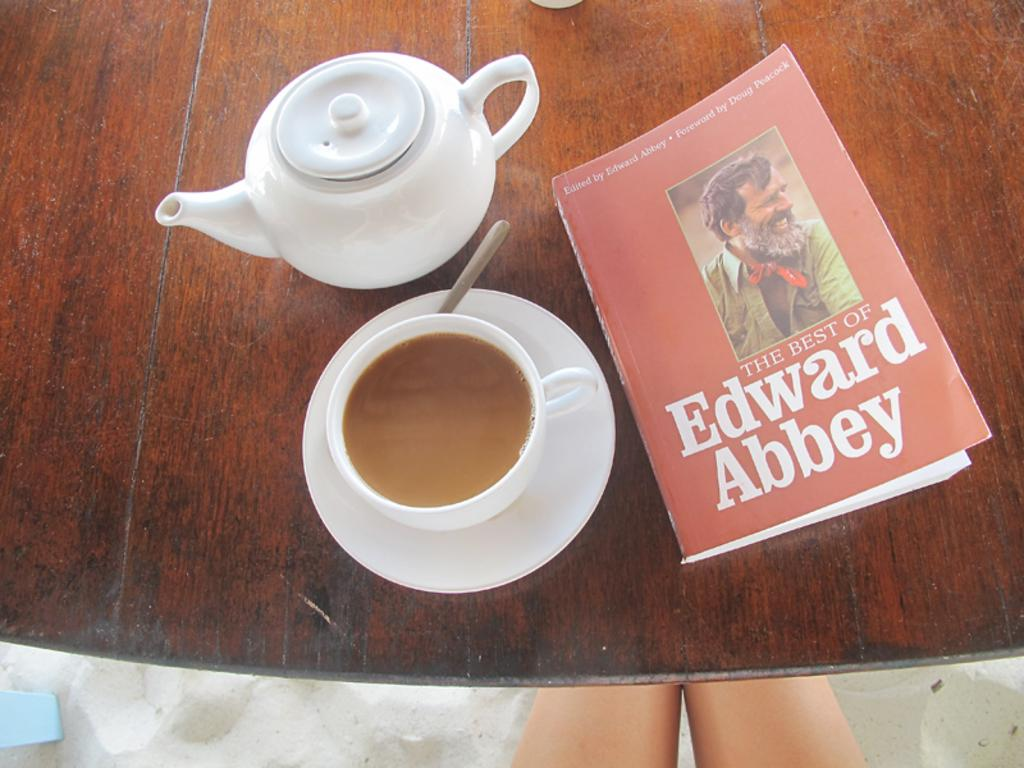<image>
Give a short and clear explanation of the subsequent image. A tea kettle and a cup of tea are on the table with a book titled "The Best of Edward Abbey." 